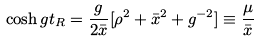<formula> <loc_0><loc_0><loc_500><loc_500>\cosh g t _ { R } = \frac { g } { 2 \bar { x } } [ \rho ^ { 2 } + \bar { x } ^ { 2 } + g ^ { - 2 } ] \equiv \frac { \mu } { \bar { x } }</formula> 